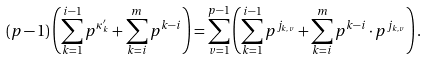<formula> <loc_0><loc_0><loc_500><loc_500>( p - 1 ) \left ( \sum _ { k = 1 } ^ { i - 1 } p ^ { \kappa ^ { \prime } _ { k } } + \sum _ { k = i } ^ { m } p ^ { k - i } \right ) = \sum _ { v = 1 } ^ { p - 1 } \left ( \sum _ { k = 1 } ^ { i - 1 } p ^ { j _ { k , v } } + \sum _ { k = i } ^ { m } p ^ { k - i } \cdot p ^ { j _ { k , v } } \right ) .</formula> 